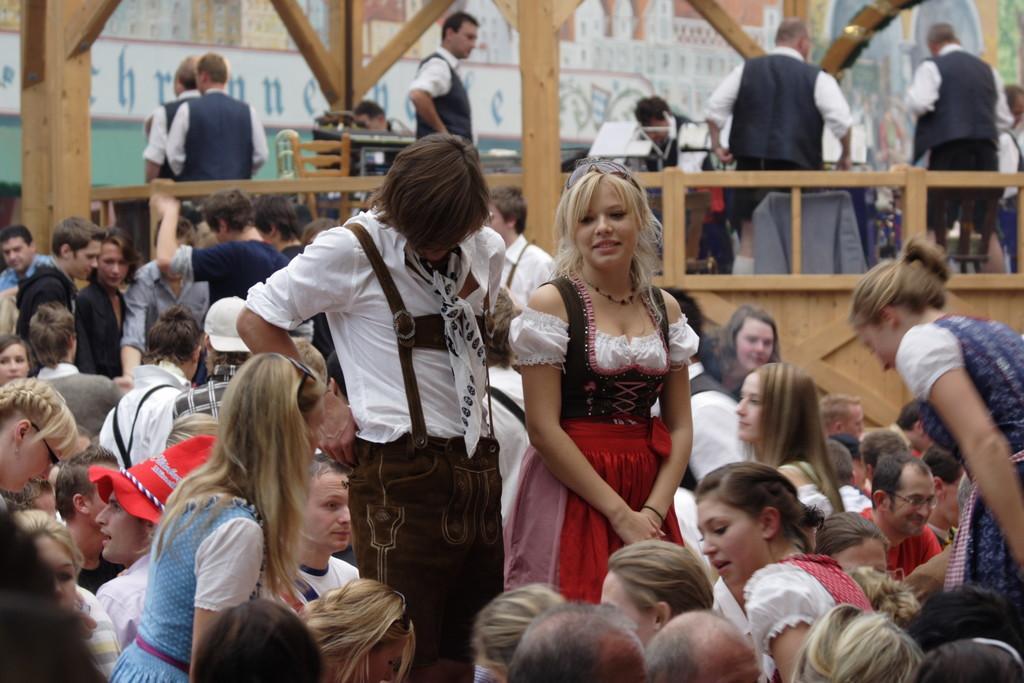How many people are in the image? There are many people standing and sitting in the image. Can you describe the setting where some of the people are located? There are people standing on a wooden bridge in the background of the image. What are the people on the bridge doing? These people on the bridge are playing music. What type of jam can be seen in the image? There is no jam present in the image. How many fans are visible in the image? There is no fan present in the image. 